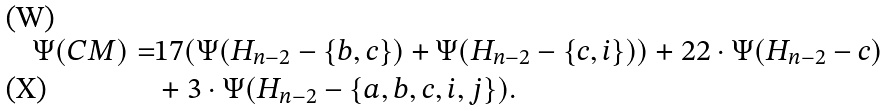Convert formula to latex. <formula><loc_0><loc_0><loc_500><loc_500>\Psi ( C M ) = & 1 7 ( \Psi ( H _ { n - 2 } - \{ b , c \} ) + \Psi ( H _ { n - 2 } - \{ c , i \} ) ) + 2 2 \cdot \Psi ( H _ { n - 2 } - c ) \\ & + 3 \cdot \Psi ( H _ { n - 2 } - \{ a , b , c , i , j \} ) .</formula> 